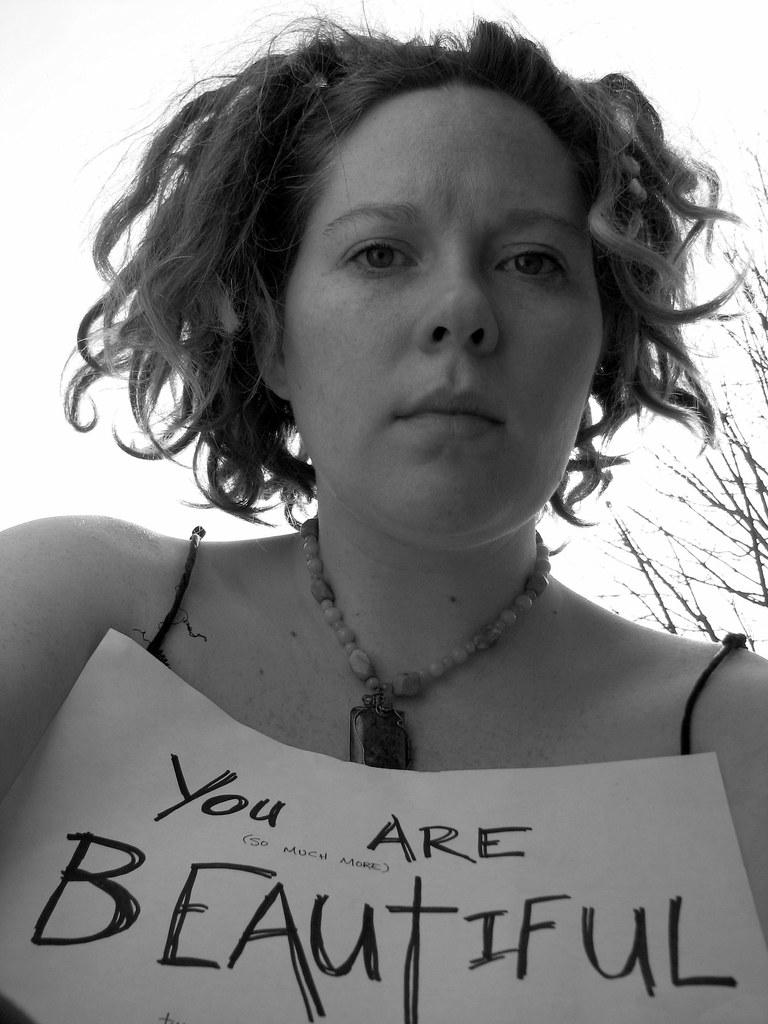What is the color scheme of the image? The image is black and white. Who is present in the image? There is a woman in the image. What is the woman holding in the image? The woman is holding a note. What message is written on the note? The note has the words "you are beautiful" written on it. What type of fireman is present in the image? There is no fireman present in the image; it features a woman holding a note with a message. 